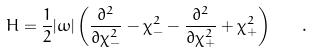Convert formula to latex. <formula><loc_0><loc_0><loc_500><loc_500>H = \frac { 1 } { 2 } | \omega | \left ( \frac { \partial ^ { 2 } } { \partial \chi _ { - } ^ { 2 } } - \chi _ { - } ^ { 2 } - \frac { \partial ^ { 2 } } { \partial \chi _ { + } ^ { 2 } } + \chi _ { + } ^ { 2 } \right ) \quad .</formula> 